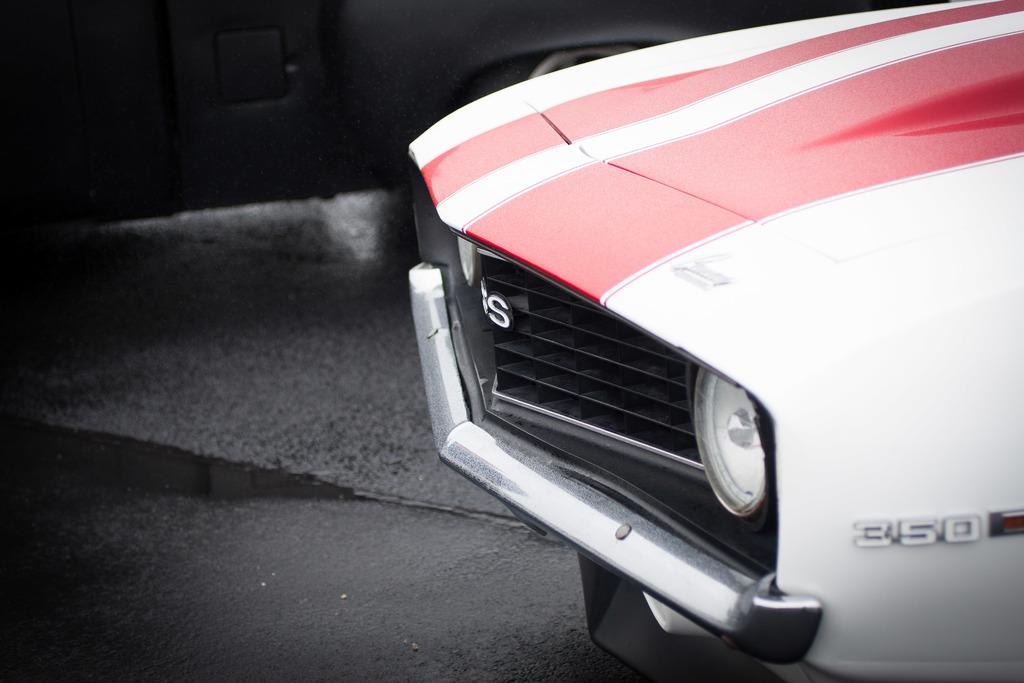What part of a car is visible in the image? The image contains the front part of a car. How many headlights are on the car? There are two headlights on the car. What feature is present at the front of the car? There is a bumper on the car. What type of apples can be seen hanging from the car's bumper in the image? There is no apple or any fruit present in the image, and therefore no such activity can be observed. 